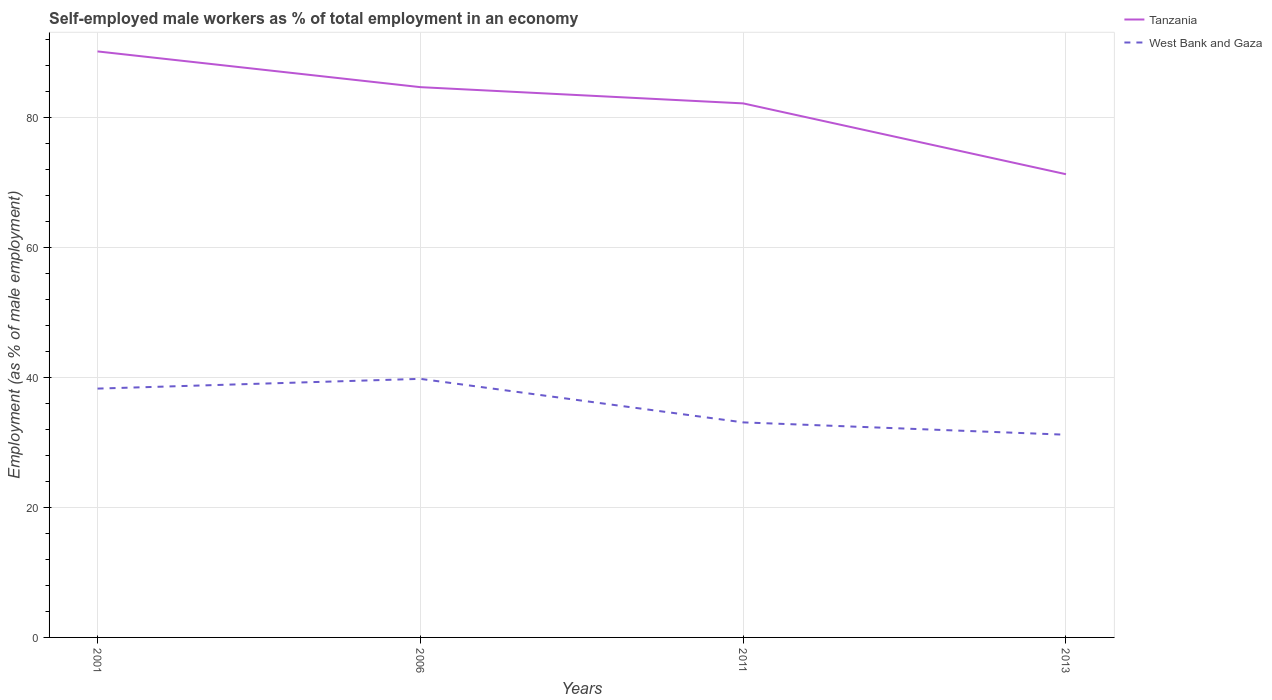Does the line corresponding to Tanzania intersect with the line corresponding to West Bank and Gaza?
Give a very brief answer. No. Is the number of lines equal to the number of legend labels?
Give a very brief answer. Yes. Across all years, what is the maximum percentage of self-employed male workers in Tanzania?
Ensure brevity in your answer.  71.3. In which year was the percentage of self-employed male workers in Tanzania maximum?
Offer a terse response. 2013. What is the total percentage of self-employed male workers in West Bank and Gaza in the graph?
Give a very brief answer. 6.7. What is the difference between the highest and the second highest percentage of self-employed male workers in Tanzania?
Your response must be concise. 18.9. What is the difference between the highest and the lowest percentage of self-employed male workers in Tanzania?
Your answer should be compact. 3. Is the percentage of self-employed male workers in Tanzania strictly greater than the percentage of self-employed male workers in West Bank and Gaza over the years?
Your answer should be very brief. No. How many lines are there?
Your answer should be compact. 2. Does the graph contain any zero values?
Give a very brief answer. No. How are the legend labels stacked?
Your answer should be very brief. Vertical. What is the title of the graph?
Provide a succinct answer. Self-employed male workers as % of total employment in an economy. What is the label or title of the Y-axis?
Ensure brevity in your answer.  Employment (as % of male employment). What is the Employment (as % of male employment) of Tanzania in 2001?
Keep it short and to the point. 90.2. What is the Employment (as % of male employment) in West Bank and Gaza in 2001?
Your answer should be very brief. 38.3. What is the Employment (as % of male employment) of Tanzania in 2006?
Your answer should be very brief. 84.7. What is the Employment (as % of male employment) in West Bank and Gaza in 2006?
Offer a very short reply. 39.8. What is the Employment (as % of male employment) in Tanzania in 2011?
Offer a terse response. 82.2. What is the Employment (as % of male employment) in West Bank and Gaza in 2011?
Your answer should be compact. 33.1. What is the Employment (as % of male employment) of Tanzania in 2013?
Give a very brief answer. 71.3. What is the Employment (as % of male employment) in West Bank and Gaza in 2013?
Ensure brevity in your answer.  31.2. Across all years, what is the maximum Employment (as % of male employment) of Tanzania?
Ensure brevity in your answer.  90.2. Across all years, what is the maximum Employment (as % of male employment) of West Bank and Gaza?
Provide a succinct answer. 39.8. Across all years, what is the minimum Employment (as % of male employment) in Tanzania?
Provide a succinct answer. 71.3. Across all years, what is the minimum Employment (as % of male employment) of West Bank and Gaza?
Your response must be concise. 31.2. What is the total Employment (as % of male employment) in Tanzania in the graph?
Keep it short and to the point. 328.4. What is the total Employment (as % of male employment) in West Bank and Gaza in the graph?
Keep it short and to the point. 142.4. What is the difference between the Employment (as % of male employment) in West Bank and Gaza in 2001 and that in 2006?
Offer a very short reply. -1.5. What is the difference between the Employment (as % of male employment) of Tanzania in 2001 and that in 2011?
Give a very brief answer. 8. What is the difference between the Employment (as % of male employment) in West Bank and Gaza in 2001 and that in 2011?
Your response must be concise. 5.2. What is the difference between the Employment (as % of male employment) in Tanzania in 2001 and that in 2013?
Offer a very short reply. 18.9. What is the difference between the Employment (as % of male employment) of West Bank and Gaza in 2001 and that in 2013?
Offer a terse response. 7.1. What is the difference between the Employment (as % of male employment) in West Bank and Gaza in 2006 and that in 2011?
Ensure brevity in your answer.  6.7. What is the difference between the Employment (as % of male employment) of Tanzania in 2006 and that in 2013?
Offer a very short reply. 13.4. What is the difference between the Employment (as % of male employment) of Tanzania in 2001 and the Employment (as % of male employment) of West Bank and Gaza in 2006?
Provide a short and direct response. 50.4. What is the difference between the Employment (as % of male employment) of Tanzania in 2001 and the Employment (as % of male employment) of West Bank and Gaza in 2011?
Make the answer very short. 57.1. What is the difference between the Employment (as % of male employment) in Tanzania in 2001 and the Employment (as % of male employment) in West Bank and Gaza in 2013?
Ensure brevity in your answer.  59. What is the difference between the Employment (as % of male employment) of Tanzania in 2006 and the Employment (as % of male employment) of West Bank and Gaza in 2011?
Make the answer very short. 51.6. What is the difference between the Employment (as % of male employment) of Tanzania in 2006 and the Employment (as % of male employment) of West Bank and Gaza in 2013?
Your answer should be compact. 53.5. What is the difference between the Employment (as % of male employment) of Tanzania in 2011 and the Employment (as % of male employment) of West Bank and Gaza in 2013?
Make the answer very short. 51. What is the average Employment (as % of male employment) of Tanzania per year?
Provide a short and direct response. 82.1. What is the average Employment (as % of male employment) of West Bank and Gaza per year?
Offer a very short reply. 35.6. In the year 2001, what is the difference between the Employment (as % of male employment) in Tanzania and Employment (as % of male employment) in West Bank and Gaza?
Your answer should be compact. 51.9. In the year 2006, what is the difference between the Employment (as % of male employment) of Tanzania and Employment (as % of male employment) of West Bank and Gaza?
Provide a succinct answer. 44.9. In the year 2011, what is the difference between the Employment (as % of male employment) of Tanzania and Employment (as % of male employment) of West Bank and Gaza?
Your response must be concise. 49.1. In the year 2013, what is the difference between the Employment (as % of male employment) of Tanzania and Employment (as % of male employment) of West Bank and Gaza?
Your answer should be very brief. 40.1. What is the ratio of the Employment (as % of male employment) of Tanzania in 2001 to that in 2006?
Provide a succinct answer. 1.06. What is the ratio of the Employment (as % of male employment) of West Bank and Gaza in 2001 to that in 2006?
Your answer should be very brief. 0.96. What is the ratio of the Employment (as % of male employment) of Tanzania in 2001 to that in 2011?
Your answer should be very brief. 1.1. What is the ratio of the Employment (as % of male employment) of West Bank and Gaza in 2001 to that in 2011?
Provide a succinct answer. 1.16. What is the ratio of the Employment (as % of male employment) in Tanzania in 2001 to that in 2013?
Offer a terse response. 1.27. What is the ratio of the Employment (as % of male employment) in West Bank and Gaza in 2001 to that in 2013?
Give a very brief answer. 1.23. What is the ratio of the Employment (as % of male employment) of Tanzania in 2006 to that in 2011?
Make the answer very short. 1.03. What is the ratio of the Employment (as % of male employment) of West Bank and Gaza in 2006 to that in 2011?
Keep it short and to the point. 1.2. What is the ratio of the Employment (as % of male employment) of Tanzania in 2006 to that in 2013?
Your answer should be very brief. 1.19. What is the ratio of the Employment (as % of male employment) of West Bank and Gaza in 2006 to that in 2013?
Offer a very short reply. 1.28. What is the ratio of the Employment (as % of male employment) of Tanzania in 2011 to that in 2013?
Offer a terse response. 1.15. What is the ratio of the Employment (as % of male employment) of West Bank and Gaza in 2011 to that in 2013?
Your response must be concise. 1.06. What is the difference between the highest and the second highest Employment (as % of male employment) of Tanzania?
Provide a short and direct response. 5.5. What is the difference between the highest and the second highest Employment (as % of male employment) in West Bank and Gaza?
Your response must be concise. 1.5. What is the difference between the highest and the lowest Employment (as % of male employment) in Tanzania?
Your answer should be very brief. 18.9. 